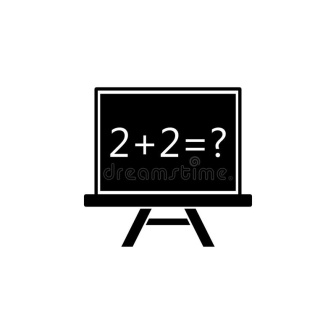What could be a humorous twist involving this image? Imagine if this chalkboard stood in a classroom for future comedians. The equation '2 + 2 = ?' is actually a setup for a joke. The teacher asks the class, and a student raises their hand and confidently replies, '2 + 2 equals four-tunate to have such a good teacher!' The class burst into laughter, and the teacher grins, knowing that humor and learning can sometimes go hand-in-hand. 